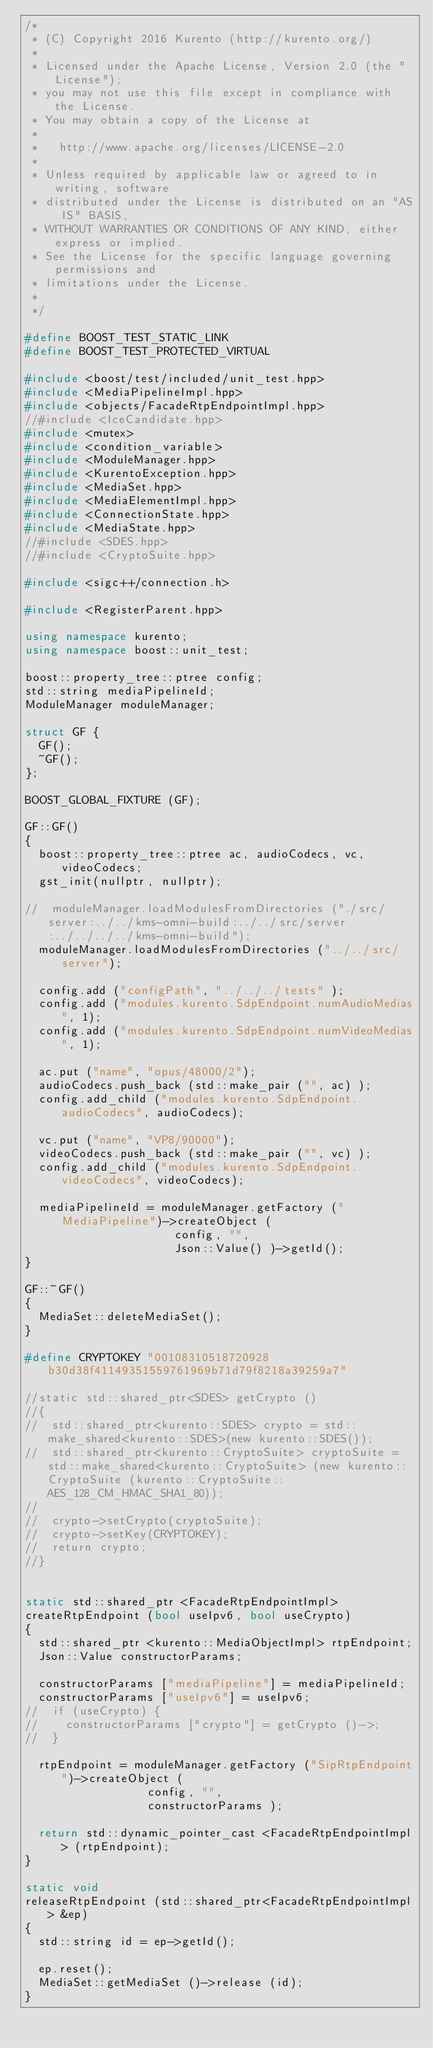Convert code to text. <code><loc_0><loc_0><loc_500><loc_500><_C++_>/*
 * (C) Copyright 2016 Kurento (http://kurento.org/)
 *
 * Licensed under the Apache License, Version 2.0 (the "License");
 * you may not use this file except in compliance with the License.
 * You may obtain a copy of the License at
 *
 *   http://www.apache.org/licenses/LICENSE-2.0
 *
 * Unless required by applicable law or agreed to in writing, software
 * distributed under the License is distributed on an "AS IS" BASIS,
 * WITHOUT WARRANTIES OR CONDITIONS OF ANY KIND, either express or implied.
 * See the License for the specific language governing permissions and
 * limitations under the License.
 *
 */

#define BOOST_TEST_STATIC_LINK
#define BOOST_TEST_PROTECTED_VIRTUAL

#include <boost/test/included/unit_test.hpp>
#include <MediaPipelineImpl.hpp>
#include <objects/FacadeRtpEndpointImpl.hpp>
//#include <IceCandidate.hpp>
#include <mutex>
#include <condition_variable>
#include <ModuleManager.hpp>
#include <KurentoException.hpp>
#include <MediaSet.hpp>
#include <MediaElementImpl.hpp>
#include <ConnectionState.hpp>
#include <MediaState.hpp>
//#include <SDES.hpp>
//#include <CryptoSuite.hpp>

#include <sigc++/connection.h>

#include <RegisterParent.hpp>

using namespace kurento;
using namespace boost::unit_test;

boost::property_tree::ptree config;
std::string mediaPipelineId;
ModuleManager moduleManager;

struct GF {
  GF();
  ~GF();
};

BOOST_GLOBAL_FIXTURE (GF);

GF::GF()
{
  boost::property_tree::ptree ac, audioCodecs, vc, videoCodecs;
  gst_init(nullptr, nullptr);

//  moduleManager.loadModulesFromDirectories ("./src/server:../../kms-omni-build:../../src/server:../../../../kms-omni-build");
  moduleManager.loadModulesFromDirectories ("../../src/server");

  config.add ("configPath", "../../../tests" );
  config.add ("modules.kurento.SdpEndpoint.numAudioMedias", 1);
  config.add ("modules.kurento.SdpEndpoint.numVideoMedias", 1);

  ac.put ("name", "opus/48000/2");
  audioCodecs.push_back (std::make_pair ("", ac) );
  config.add_child ("modules.kurento.SdpEndpoint.audioCodecs", audioCodecs);

  vc.put ("name", "VP8/90000");
  videoCodecs.push_back (std::make_pair ("", vc) );
  config.add_child ("modules.kurento.SdpEndpoint.videoCodecs", videoCodecs);

  mediaPipelineId = moduleManager.getFactory ("MediaPipeline")->createObject (
                      config, "",
                      Json::Value() )->getId();
}

GF::~GF()
{
  MediaSet::deleteMediaSet();
}

#define CRYPTOKEY "00108310518720928b30d38f41149351559761969b71d79f8218a39259a7"

//static std::shared_ptr<SDES> getCrypto ()
//{
//	std::shared_ptr<kurento::SDES> crypto = std::make_shared<kurento::SDES>(new kurento::SDES());
//	std::shared_ptr<kurento::CryptoSuite> cryptoSuite = std::make_shared<kurento::CryptoSuite> (new kurento::CryptoSuite (kurento::CryptoSuite::AES_128_CM_HMAC_SHA1_80));
//
//	crypto->setCrypto(cryptoSuite);
//	crypto->setKey(CRYPTOKEY);
//	return crypto;
//}


static std::shared_ptr <FacadeRtpEndpointImpl>
createRtpEndpoint (bool useIpv6, bool useCrypto)
{
  std::shared_ptr <kurento::MediaObjectImpl> rtpEndpoint;
  Json::Value constructorParams;

  constructorParams ["mediaPipeline"] = mediaPipelineId;
  constructorParams ["useIpv6"] = useIpv6;
//  if (useCrypto) {
//	  constructorParams ["crypto"] = getCrypto ()->;
//  }

  rtpEndpoint = moduleManager.getFactory ("SipRtpEndpoint")->createObject (
                  config, "",
                  constructorParams );

  return std::dynamic_pointer_cast <FacadeRtpEndpointImpl> (rtpEndpoint);
}

static void
releaseRtpEndpoint (std::shared_ptr<FacadeRtpEndpointImpl> &ep)
{
  std::string id = ep->getId();

  ep.reset();
  MediaSet::getMediaSet ()->release (id);
}
</code> 